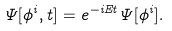Convert formula to latex. <formula><loc_0><loc_0><loc_500><loc_500>\Psi [ \phi ^ { i } , t ] = e ^ { - i E t } \Psi [ \phi ^ { i } ] .</formula> 